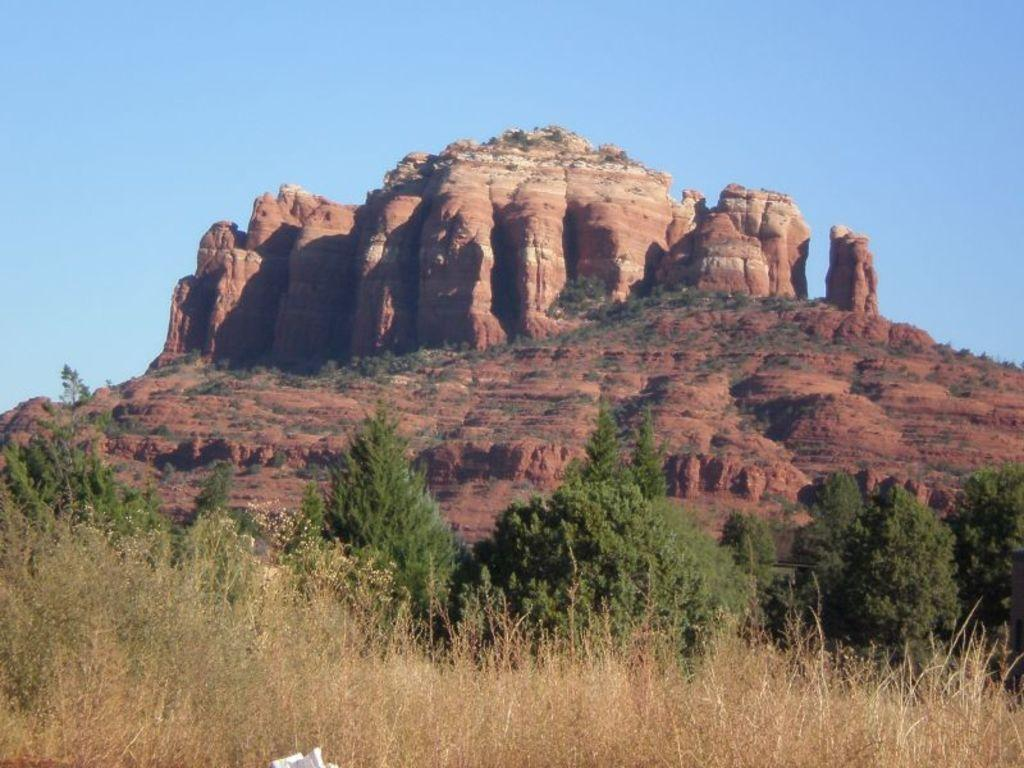What geographical feature is the main subject of the image? There is a mountain in the image. What can be observed about the mountain's composition? The mountain has huge rocks. What type of vegetation is present in front of the mountain? There are trees and dry plants in front of the mountain. Can you hear the bells ringing in the image? There are no bells present in the image, so it is not possible to hear them ringing. 